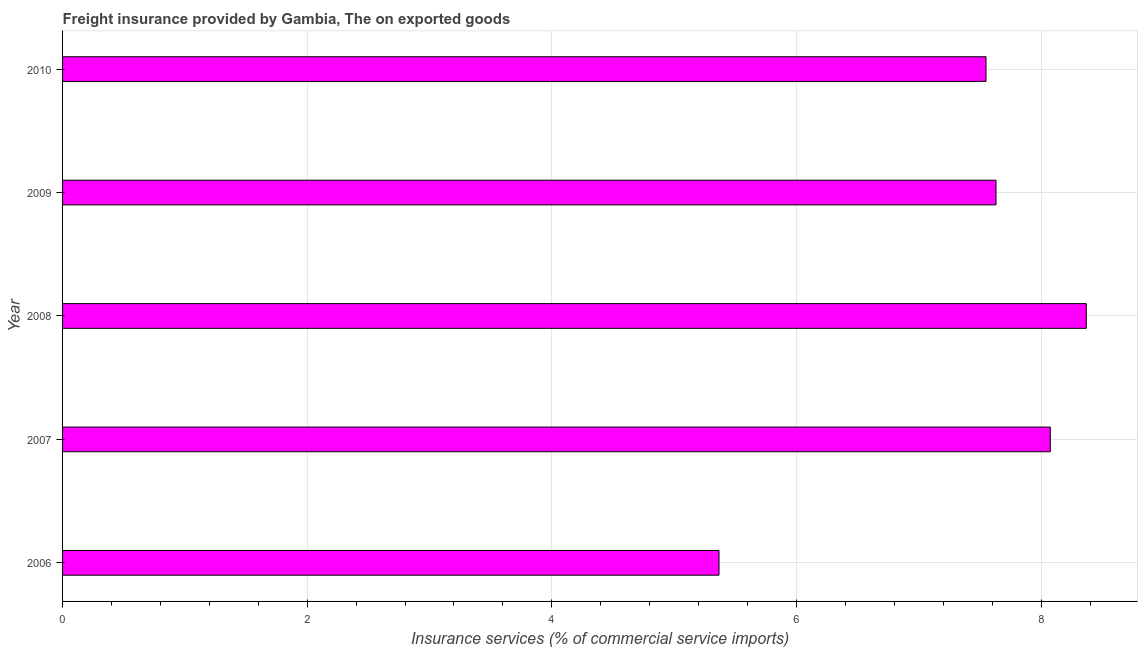What is the title of the graph?
Offer a very short reply. Freight insurance provided by Gambia, The on exported goods . What is the label or title of the X-axis?
Give a very brief answer. Insurance services (% of commercial service imports). What is the freight insurance in 2006?
Offer a terse response. 5.37. Across all years, what is the maximum freight insurance?
Offer a terse response. 8.37. Across all years, what is the minimum freight insurance?
Provide a succinct answer. 5.37. In which year was the freight insurance maximum?
Provide a succinct answer. 2008. In which year was the freight insurance minimum?
Your answer should be compact. 2006. What is the sum of the freight insurance?
Your answer should be compact. 36.99. What is the difference between the freight insurance in 2008 and 2009?
Offer a terse response. 0.74. What is the average freight insurance per year?
Offer a very short reply. 7.4. What is the median freight insurance?
Ensure brevity in your answer.  7.63. In how many years, is the freight insurance greater than 5.2 %?
Give a very brief answer. 5. Do a majority of the years between 2009 and 2006 (inclusive) have freight insurance greater than 7.6 %?
Ensure brevity in your answer.  Yes. What is the ratio of the freight insurance in 2006 to that in 2007?
Provide a succinct answer. 0.67. Is the freight insurance in 2007 less than that in 2009?
Your answer should be compact. No. Is the difference between the freight insurance in 2007 and 2008 greater than the difference between any two years?
Give a very brief answer. No. What is the difference between the highest and the second highest freight insurance?
Your response must be concise. 0.29. How many bars are there?
Your response must be concise. 5. How many years are there in the graph?
Give a very brief answer. 5. What is the difference between two consecutive major ticks on the X-axis?
Offer a terse response. 2. Are the values on the major ticks of X-axis written in scientific E-notation?
Give a very brief answer. No. What is the Insurance services (% of commercial service imports) in 2006?
Make the answer very short. 5.37. What is the Insurance services (% of commercial service imports) in 2007?
Give a very brief answer. 8.08. What is the Insurance services (% of commercial service imports) in 2008?
Offer a very short reply. 8.37. What is the Insurance services (% of commercial service imports) in 2009?
Provide a short and direct response. 7.63. What is the Insurance services (% of commercial service imports) of 2010?
Give a very brief answer. 7.55. What is the difference between the Insurance services (% of commercial service imports) in 2006 and 2007?
Provide a short and direct response. -2.71. What is the difference between the Insurance services (% of commercial service imports) in 2006 and 2008?
Ensure brevity in your answer.  -3. What is the difference between the Insurance services (% of commercial service imports) in 2006 and 2009?
Keep it short and to the point. -2.26. What is the difference between the Insurance services (% of commercial service imports) in 2006 and 2010?
Your response must be concise. -2.18. What is the difference between the Insurance services (% of commercial service imports) in 2007 and 2008?
Give a very brief answer. -0.29. What is the difference between the Insurance services (% of commercial service imports) in 2007 and 2009?
Give a very brief answer. 0.44. What is the difference between the Insurance services (% of commercial service imports) in 2007 and 2010?
Offer a terse response. 0.53. What is the difference between the Insurance services (% of commercial service imports) in 2008 and 2009?
Your response must be concise. 0.74. What is the difference between the Insurance services (% of commercial service imports) in 2008 and 2010?
Offer a very short reply. 0.82. What is the difference between the Insurance services (% of commercial service imports) in 2009 and 2010?
Your answer should be very brief. 0.08. What is the ratio of the Insurance services (% of commercial service imports) in 2006 to that in 2007?
Your response must be concise. 0.67. What is the ratio of the Insurance services (% of commercial service imports) in 2006 to that in 2008?
Your response must be concise. 0.64. What is the ratio of the Insurance services (% of commercial service imports) in 2006 to that in 2009?
Your answer should be compact. 0.7. What is the ratio of the Insurance services (% of commercial service imports) in 2006 to that in 2010?
Ensure brevity in your answer.  0.71. What is the ratio of the Insurance services (% of commercial service imports) in 2007 to that in 2008?
Keep it short and to the point. 0.96. What is the ratio of the Insurance services (% of commercial service imports) in 2007 to that in 2009?
Provide a short and direct response. 1.06. What is the ratio of the Insurance services (% of commercial service imports) in 2007 to that in 2010?
Keep it short and to the point. 1.07. What is the ratio of the Insurance services (% of commercial service imports) in 2008 to that in 2009?
Provide a succinct answer. 1.1. What is the ratio of the Insurance services (% of commercial service imports) in 2008 to that in 2010?
Offer a very short reply. 1.11. What is the ratio of the Insurance services (% of commercial service imports) in 2009 to that in 2010?
Offer a terse response. 1.01. 